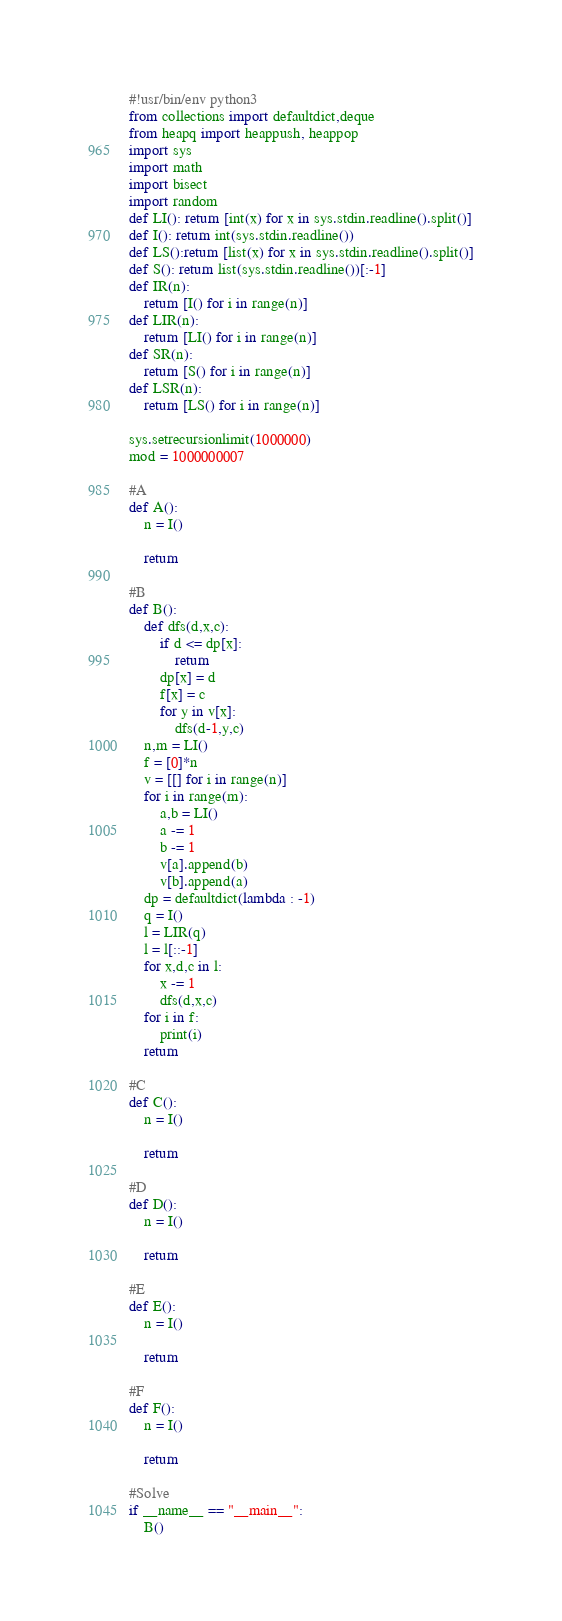<code> <loc_0><loc_0><loc_500><loc_500><_Python_>#!usr/bin/env python3
from collections import defaultdict,deque
from heapq import heappush, heappop
import sys
import math
import bisect
import random
def LI(): return [int(x) for x in sys.stdin.readline().split()]
def I(): return int(sys.stdin.readline())
def LS():return [list(x) for x in sys.stdin.readline().split()]
def S(): return list(sys.stdin.readline())[:-1]
def IR(n):
    return [I() for i in range(n)]
def LIR(n):
    return [LI() for i in range(n)]
def SR(n):
    return [S() for i in range(n)]
def LSR(n):
    return [LS() for i in range(n)]

sys.setrecursionlimit(1000000)
mod = 1000000007

#A
def A():
    n = I()

    return

#B
def B():
    def dfs(d,x,c):
        if d <= dp[x]:
            return
        dp[x] = d
        f[x] = c
        for y in v[x]:
            dfs(d-1,y,c)
    n,m = LI()
    f = [0]*n
    v = [[] for i in range(n)]
    for i in range(m):
        a,b = LI()
        a -= 1
        b -= 1
        v[a].append(b)
        v[b].append(a)
    dp = defaultdict(lambda : -1)
    q = I()
    l = LIR(q)
    l = l[::-1]
    for x,d,c in l:
        x -= 1
        dfs(d,x,c)
    for i in f:
        print(i)
    return

#C
def C():
    n = I()

    return

#D
def D():
    n = I()

    return

#E
def E():
    n = I()

    return

#F
def F():
    n = I()

    return

#Solve
if __name__ == "__main__":
    B()
</code> 